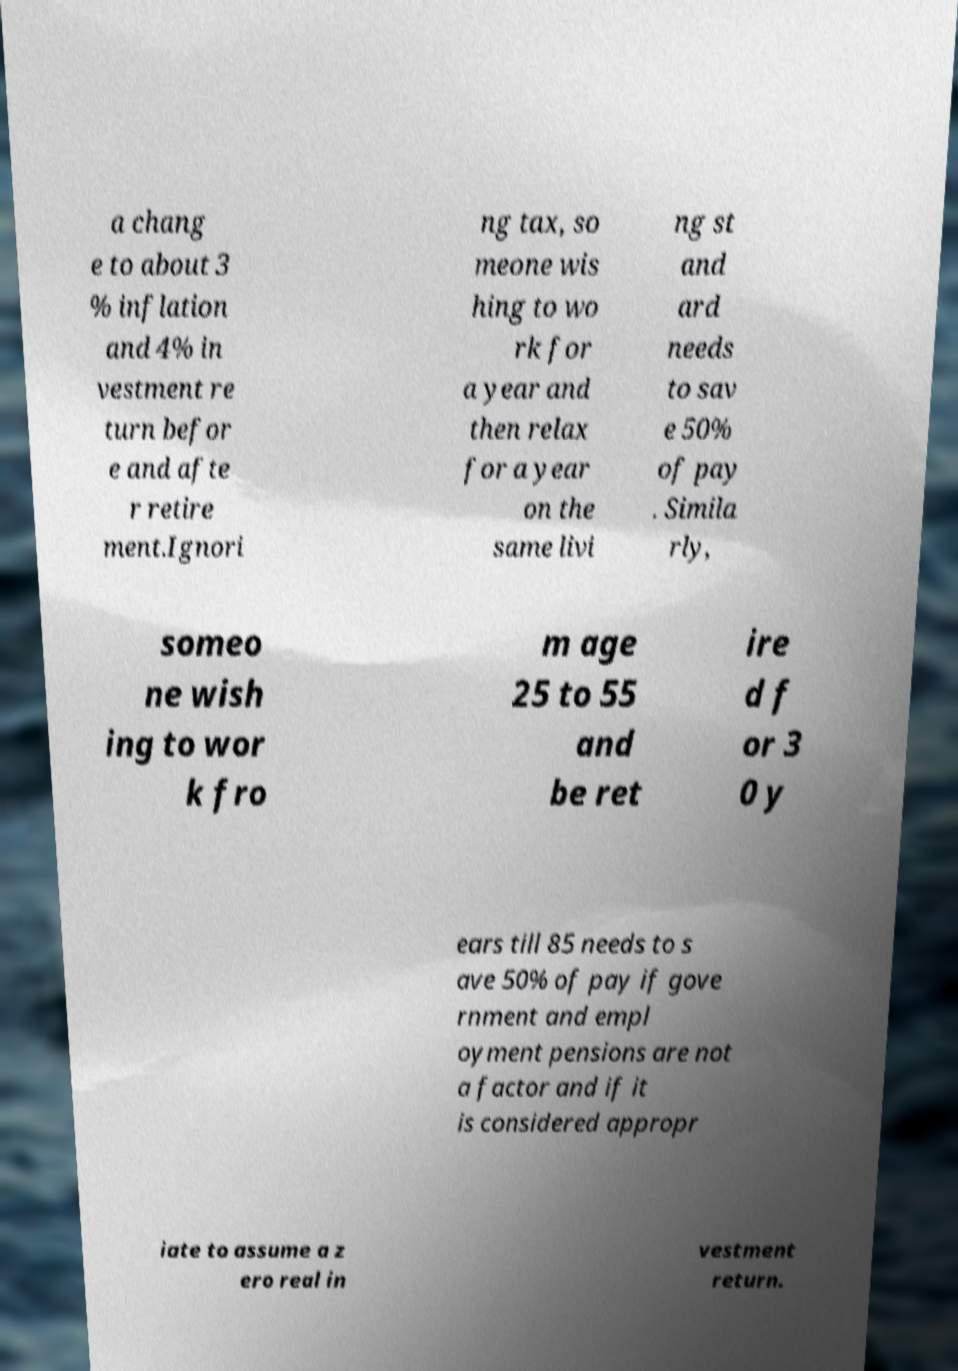Please identify and transcribe the text found in this image. a chang e to about 3 % inflation and 4% in vestment re turn befor e and afte r retire ment.Ignori ng tax, so meone wis hing to wo rk for a year and then relax for a year on the same livi ng st and ard needs to sav e 50% of pay . Simila rly, someo ne wish ing to wor k fro m age 25 to 55 and be ret ire d f or 3 0 y ears till 85 needs to s ave 50% of pay if gove rnment and empl oyment pensions are not a factor and if it is considered appropr iate to assume a z ero real in vestment return. 